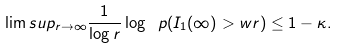Convert formula to latex. <formula><loc_0><loc_0><loc_500><loc_500>\lim s u p _ { r \to \infty } \frac { 1 } { \log r } \log \ p ( I _ { 1 } ( \infty ) > w r ) \leq 1 - \kappa .</formula> 